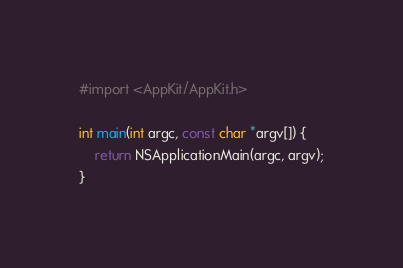Convert code to text. <code><loc_0><loc_0><loc_500><loc_500><_ObjectiveC_>#import <AppKit/AppKit.h>

int main(int argc, const char *argv[]) {
    return NSApplicationMain(argc, argv);
}
</code> 